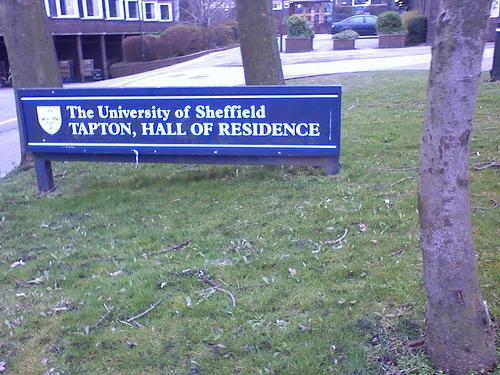Who lives in these buildings?

Choices:
A) soldiers
B) students
C) teachers
D) foster kids students 